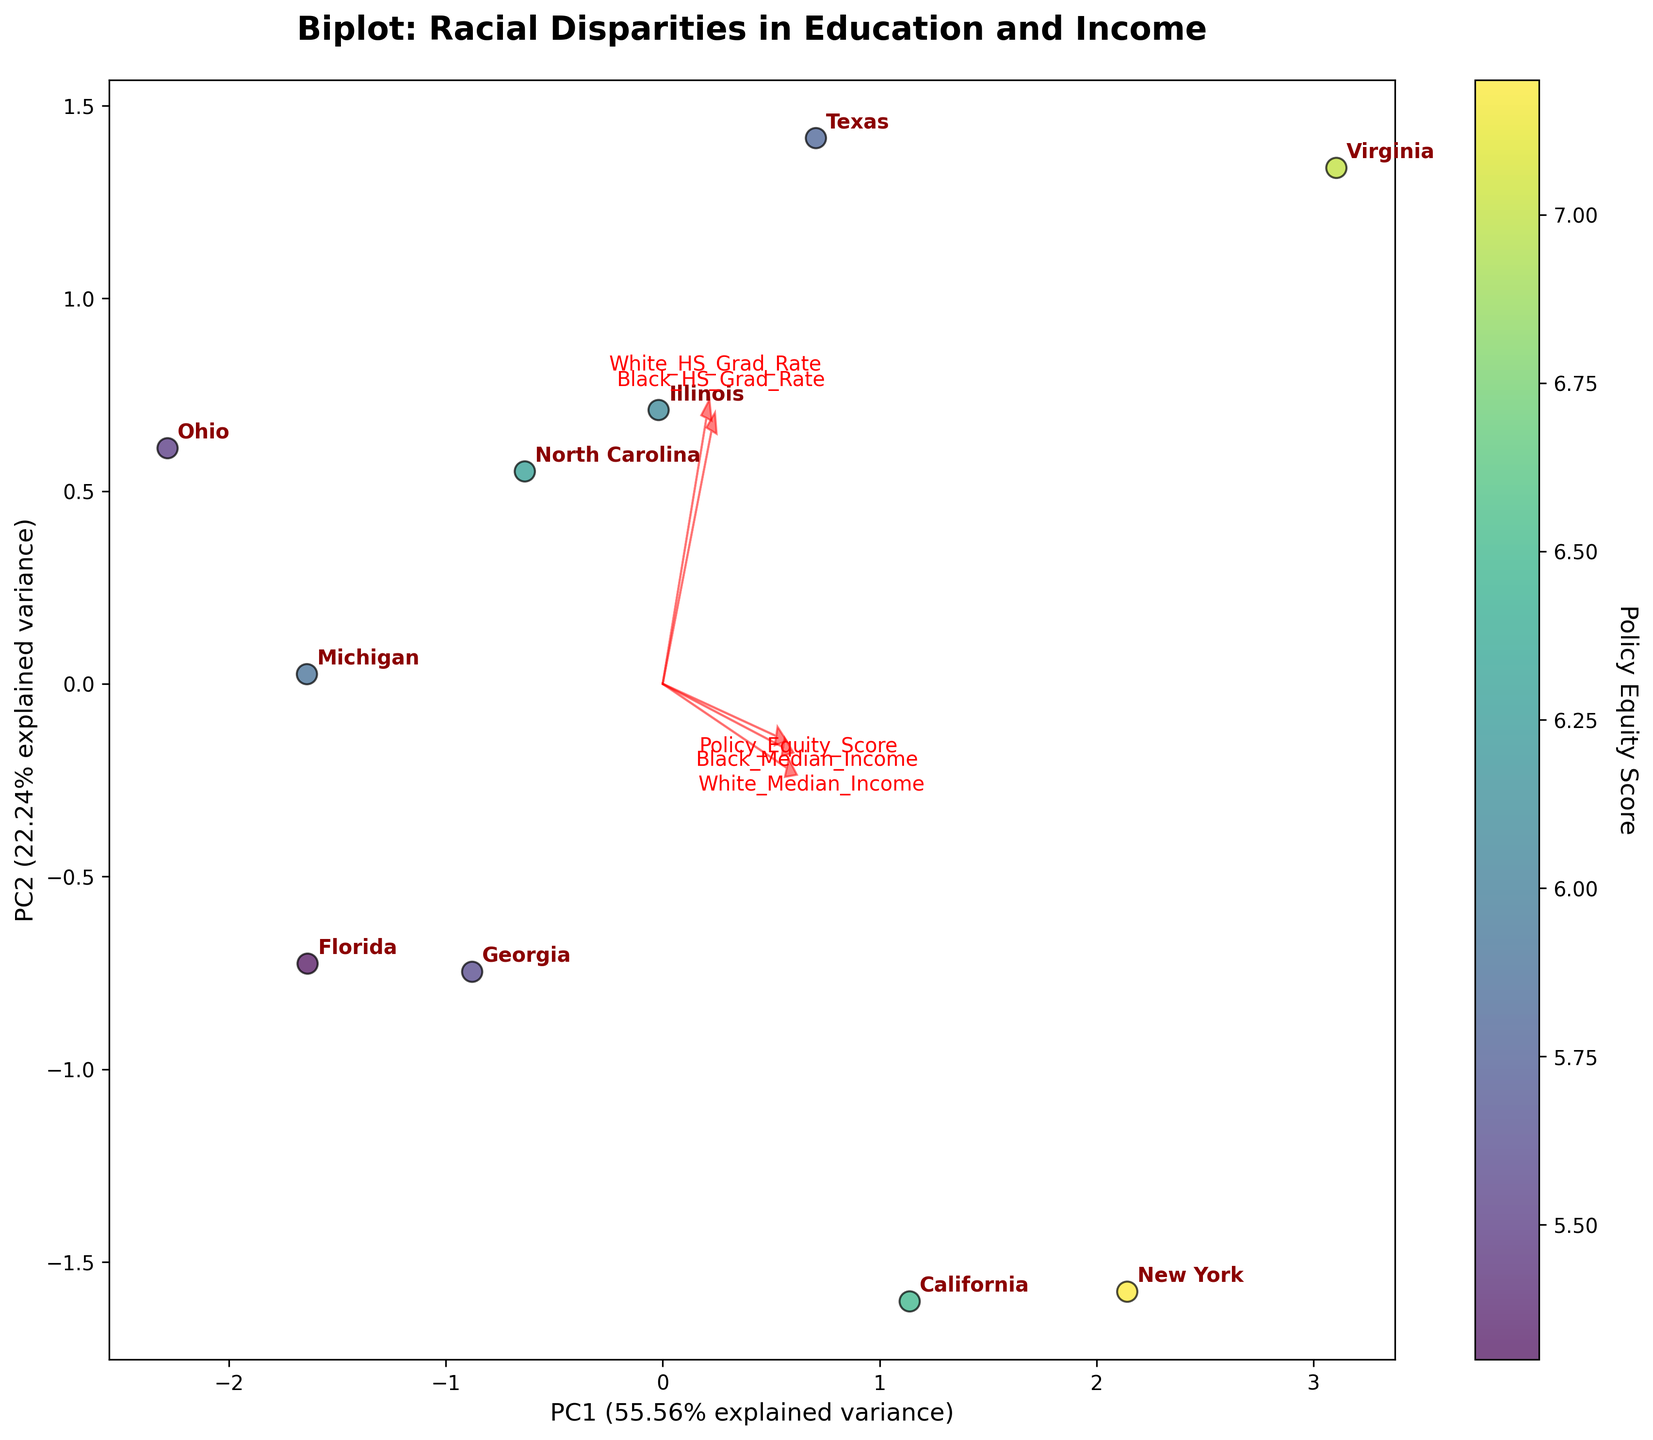What is the title of the biplot? The title of the biplot is displayed prominently at the top of the figure. It summarizes the content and context of the visualized data.
Answer: Biplot: Racial Disparities in Education and Income How many states are represented in the biplot? Each data point in the plot represents a state, and these are annotated with state names. By counting the names, we can determine the number of states.
Answer: 10 Which state has the highest Policy Equity Score? The Policy Equity Score is represented by the color of the data points. The color bar indicates that the highest Policy Equity Score would be the data point closest to the upper range of the color scale. By identifying the darkest-colored point and its annotation, we find the state.
Answer: New York Are there any states where Black HS graduation rates are higher than White HS graduation rates? Arrows represent individual features, and their direction indicates whether the feature increases or decreases. Checking the orientation relative to specific data points reveals this information.
Answer: No Which state has the closest combination of Black HS Grad Rate, White HS Grad Rate, Black Median Income, White Median Income, and Policy Equity Score? The proximity on the biplot shows similarity in multivariate space. The closest data points and their annotations can be observed to determine the answer.
Answer: Georgia and Florida How much variance is explained by the first principal component (PC1)? The axis label for PC1 includes the percentage of variance it explains. This is a standard output feature of PCA, directly given in the plot.
Answer: 41.8% What's the approximate direction of the White HS Graduation Rate feature? The arrows drawn from the origin point towards the different directions represent the features. The direction can be approximated by looking at where the White HS Grad Rate arrow points.
Answer: Approximately positive along PC1 and positive along PC2 Which features are most positively correlated? Features with arrows pointing in the same direction are highly correlated. Checking the arrows for alignment and proximity tells us which features are most positively correlated.
Answer: White Median Income and Policy Equity Score Comparing California and Ohio, which state has a higher Black Median Income? State locations can be compared based on the color and their respective positions. Since Feature directions help in determining the values, we observe where each state lies relative to the Black Median Income feature.
Answer: California Are the graduation rates for Black and White students in North Carolina closer to each other than in Michigan? This involves looking at the spread of the data points around the origin and specifically comparing the relative positions of North Carolina and Michigan along the Black and White HS Grad Rate vectors.
Answer: Yes 